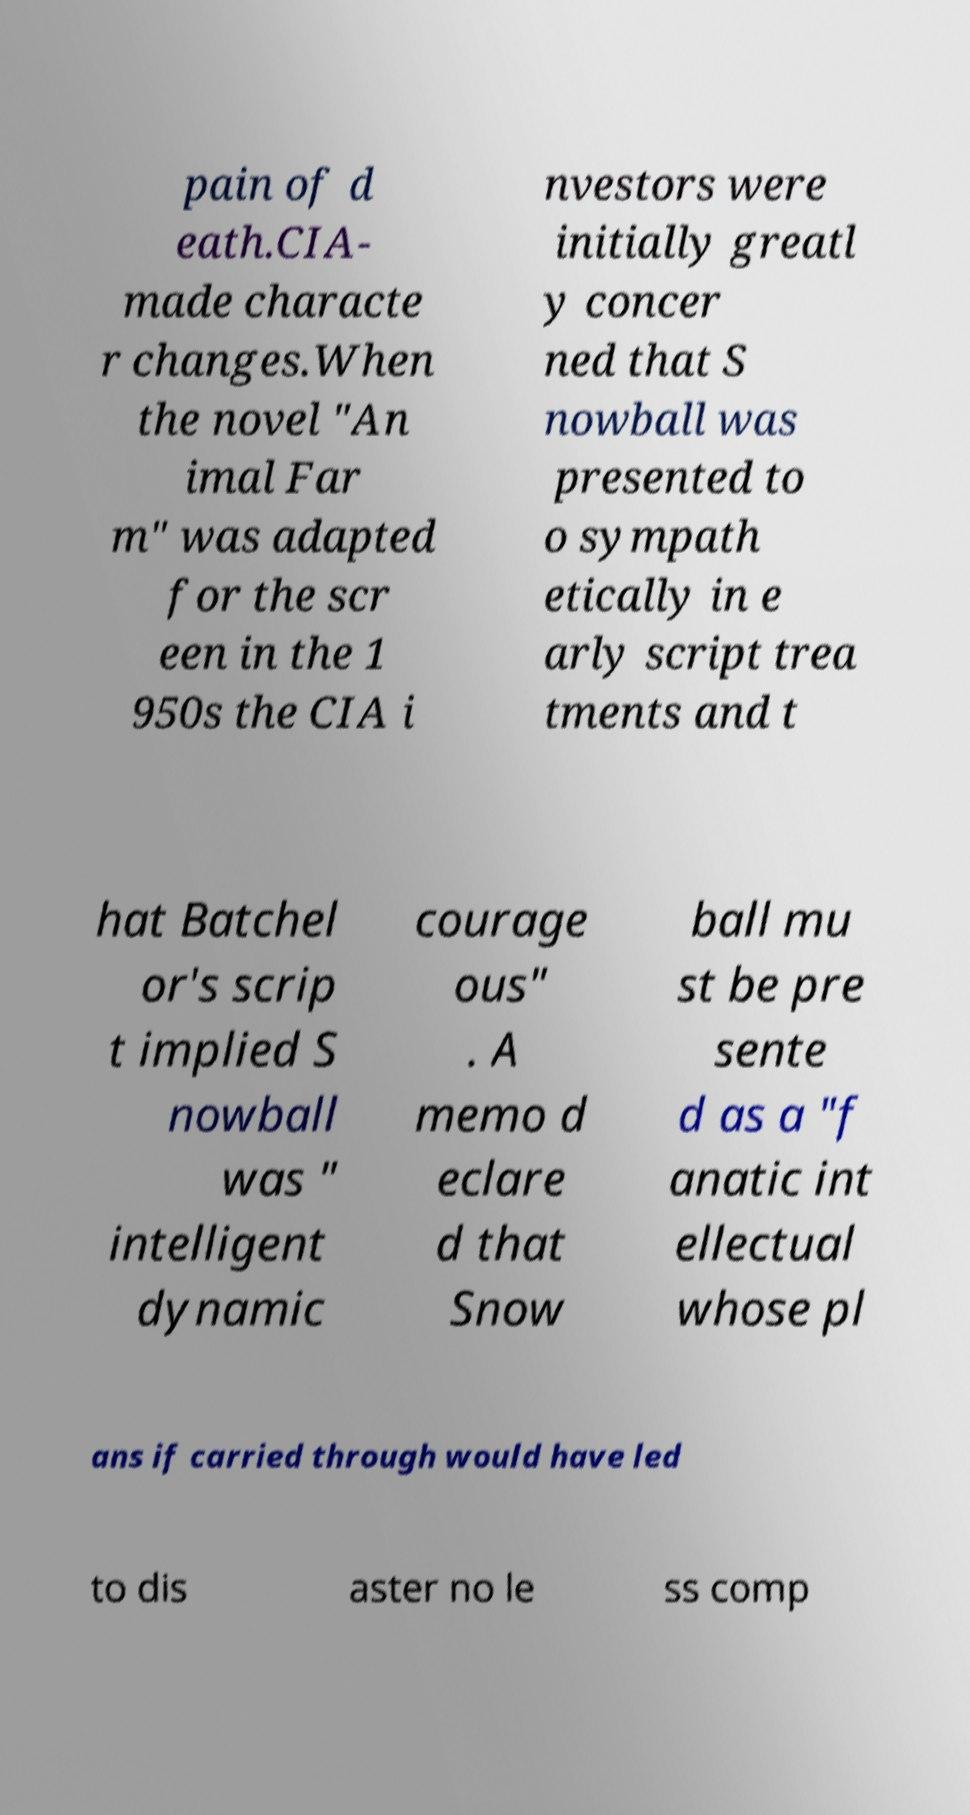Please identify and transcribe the text found in this image. pain of d eath.CIA- made characte r changes.When the novel "An imal Far m" was adapted for the scr een in the 1 950s the CIA i nvestors were initially greatl y concer ned that S nowball was presented to o sympath etically in e arly script trea tments and t hat Batchel or's scrip t implied S nowball was " intelligent dynamic courage ous" . A memo d eclare d that Snow ball mu st be pre sente d as a "f anatic int ellectual whose pl ans if carried through would have led to dis aster no le ss comp 